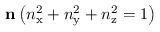<formula> <loc_0><loc_0><loc_500><loc_500>n \left ( n _ { x } ^ { 2 } + n _ { y } ^ { 2 } + n _ { z } ^ { 2 } = 1 \right )</formula> 